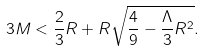<formula> <loc_0><loc_0><loc_500><loc_500>3 M < \frac { 2 } { 3 } R + R \sqrt { \frac { 4 } { 9 } - \frac { \Lambda } { 3 } R ^ { 2 } } .</formula> 